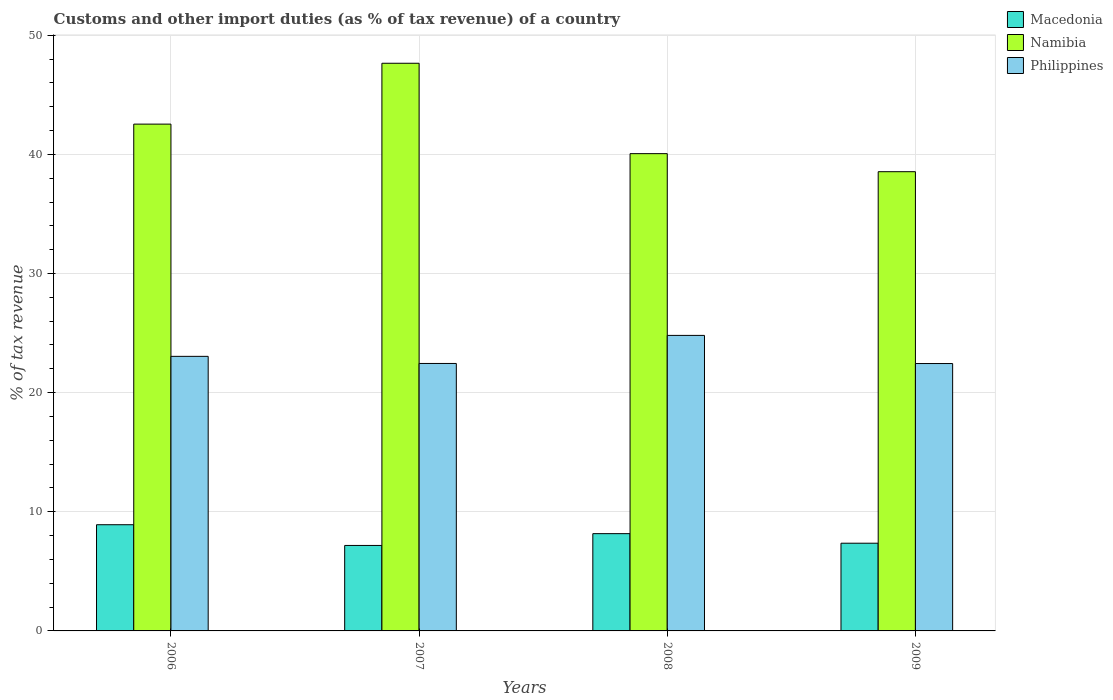How many different coloured bars are there?
Your answer should be compact. 3. How many groups of bars are there?
Your answer should be very brief. 4. What is the percentage of tax revenue from customs in Macedonia in 2008?
Your answer should be compact. 8.16. Across all years, what is the maximum percentage of tax revenue from customs in Namibia?
Keep it short and to the point. 47.65. Across all years, what is the minimum percentage of tax revenue from customs in Namibia?
Provide a short and direct response. 38.55. What is the total percentage of tax revenue from customs in Macedonia in the graph?
Your response must be concise. 31.62. What is the difference between the percentage of tax revenue from customs in Namibia in 2006 and that in 2009?
Give a very brief answer. 3.99. What is the difference between the percentage of tax revenue from customs in Namibia in 2007 and the percentage of tax revenue from customs in Macedonia in 2006?
Offer a very short reply. 38.73. What is the average percentage of tax revenue from customs in Namibia per year?
Provide a short and direct response. 42.2. In the year 2007, what is the difference between the percentage of tax revenue from customs in Macedonia and percentage of tax revenue from customs in Namibia?
Your answer should be compact. -40.47. In how many years, is the percentage of tax revenue from customs in Namibia greater than 14 %?
Your answer should be very brief. 4. What is the ratio of the percentage of tax revenue from customs in Namibia in 2006 to that in 2007?
Ensure brevity in your answer.  0.89. Is the difference between the percentage of tax revenue from customs in Macedonia in 2006 and 2008 greater than the difference between the percentage of tax revenue from customs in Namibia in 2006 and 2008?
Ensure brevity in your answer.  No. What is the difference between the highest and the second highest percentage of tax revenue from customs in Namibia?
Provide a short and direct response. 5.11. What is the difference between the highest and the lowest percentage of tax revenue from customs in Macedonia?
Ensure brevity in your answer.  1.74. In how many years, is the percentage of tax revenue from customs in Namibia greater than the average percentage of tax revenue from customs in Namibia taken over all years?
Give a very brief answer. 2. What does the 3rd bar from the left in 2007 represents?
Provide a short and direct response. Philippines. What does the 2nd bar from the right in 2008 represents?
Provide a succinct answer. Namibia. How many years are there in the graph?
Offer a terse response. 4. What is the difference between two consecutive major ticks on the Y-axis?
Provide a short and direct response. 10. Are the values on the major ticks of Y-axis written in scientific E-notation?
Ensure brevity in your answer.  No. Does the graph contain any zero values?
Keep it short and to the point. No. How many legend labels are there?
Provide a succinct answer. 3. How are the legend labels stacked?
Offer a terse response. Vertical. What is the title of the graph?
Provide a succinct answer. Customs and other import duties (as % of tax revenue) of a country. Does "Uruguay" appear as one of the legend labels in the graph?
Your response must be concise. No. What is the label or title of the X-axis?
Give a very brief answer. Years. What is the label or title of the Y-axis?
Keep it short and to the point. % of tax revenue. What is the % of tax revenue in Macedonia in 2006?
Ensure brevity in your answer.  8.91. What is the % of tax revenue in Namibia in 2006?
Give a very brief answer. 42.54. What is the % of tax revenue in Philippines in 2006?
Your response must be concise. 23.05. What is the % of tax revenue of Macedonia in 2007?
Make the answer very short. 7.17. What is the % of tax revenue in Namibia in 2007?
Make the answer very short. 47.65. What is the % of tax revenue in Philippines in 2007?
Ensure brevity in your answer.  22.45. What is the % of tax revenue in Macedonia in 2008?
Ensure brevity in your answer.  8.16. What is the % of tax revenue in Namibia in 2008?
Provide a short and direct response. 40.06. What is the % of tax revenue of Philippines in 2008?
Provide a succinct answer. 24.8. What is the % of tax revenue in Macedonia in 2009?
Your answer should be very brief. 7.36. What is the % of tax revenue in Namibia in 2009?
Make the answer very short. 38.55. What is the % of tax revenue of Philippines in 2009?
Your answer should be compact. 22.44. Across all years, what is the maximum % of tax revenue in Macedonia?
Give a very brief answer. 8.91. Across all years, what is the maximum % of tax revenue of Namibia?
Your response must be concise. 47.65. Across all years, what is the maximum % of tax revenue in Philippines?
Your answer should be compact. 24.8. Across all years, what is the minimum % of tax revenue in Macedonia?
Offer a very short reply. 7.17. Across all years, what is the minimum % of tax revenue of Namibia?
Provide a succinct answer. 38.55. Across all years, what is the minimum % of tax revenue in Philippines?
Your answer should be compact. 22.44. What is the total % of tax revenue in Macedonia in the graph?
Provide a short and direct response. 31.62. What is the total % of tax revenue of Namibia in the graph?
Keep it short and to the point. 168.79. What is the total % of tax revenue in Philippines in the graph?
Make the answer very short. 92.74. What is the difference between the % of tax revenue of Macedonia in 2006 and that in 2007?
Offer a very short reply. 1.74. What is the difference between the % of tax revenue of Namibia in 2006 and that in 2007?
Your response must be concise. -5.11. What is the difference between the % of tax revenue in Philippines in 2006 and that in 2007?
Keep it short and to the point. 0.6. What is the difference between the % of tax revenue in Macedonia in 2006 and that in 2008?
Give a very brief answer. 0.75. What is the difference between the % of tax revenue of Namibia in 2006 and that in 2008?
Your answer should be very brief. 2.48. What is the difference between the % of tax revenue of Philippines in 2006 and that in 2008?
Make the answer very short. -1.76. What is the difference between the % of tax revenue of Macedonia in 2006 and that in 2009?
Your answer should be very brief. 1.55. What is the difference between the % of tax revenue in Namibia in 2006 and that in 2009?
Your answer should be compact. 3.99. What is the difference between the % of tax revenue in Philippines in 2006 and that in 2009?
Provide a succinct answer. 0.6. What is the difference between the % of tax revenue in Macedonia in 2007 and that in 2008?
Make the answer very short. -0.99. What is the difference between the % of tax revenue in Namibia in 2007 and that in 2008?
Provide a short and direct response. 7.59. What is the difference between the % of tax revenue in Philippines in 2007 and that in 2008?
Provide a succinct answer. -2.36. What is the difference between the % of tax revenue in Macedonia in 2007 and that in 2009?
Provide a succinct answer. -0.19. What is the difference between the % of tax revenue of Namibia in 2007 and that in 2009?
Your answer should be very brief. 9.1. What is the difference between the % of tax revenue of Philippines in 2007 and that in 2009?
Offer a terse response. 0.01. What is the difference between the % of tax revenue in Macedonia in 2008 and that in 2009?
Offer a terse response. 0.8. What is the difference between the % of tax revenue of Namibia in 2008 and that in 2009?
Keep it short and to the point. 1.51. What is the difference between the % of tax revenue of Philippines in 2008 and that in 2009?
Ensure brevity in your answer.  2.36. What is the difference between the % of tax revenue in Macedonia in 2006 and the % of tax revenue in Namibia in 2007?
Your response must be concise. -38.73. What is the difference between the % of tax revenue of Macedonia in 2006 and the % of tax revenue of Philippines in 2007?
Keep it short and to the point. -13.54. What is the difference between the % of tax revenue in Namibia in 2006 and the % of tax revenue in Philippines in 2007?
Give a very brief answer. 20.09. What is the difference between the % of tax revenue of Macedonia in 2006 and the % of tax revenue of Namibia in 2008?
Provide a succinct answer. -31.15. What is the difference between the % of tax revenue of Macedonia in 2006 and the % of tax revenue of Philippines in 2008?
Make the answer very short. -15.89. What is the difference between the % of tax revenue of Namibia in 2006 and the % of tax revenue of Philippines in 2008?
Make the answer very short. 17.73. What is the difference between the % of tax revenue in Macedonia in 2006 and the % of tax revenue in Namibia in 2009?
Your answer should be very brief. -29.63. What is the difference between the % of tax revenue in Macedonia in 2006 and the % of tax revenue in Philippines in 2009?
Keep it short and to the point. -13.53. What is the difference between the % of tax revenue of Namibia in 2006 and the % of tax revenue of Philippines in 2009?
Ensure brevity in your answer.  20.1. What is the difference between the % of tax revenue of Macedonia in 2007 and the % of tax revenue of Namibia in 2008?
Offer a very short reply. -32.88. What is the difference between the % of tax revenue in Macedonia in 2007 and the % of tax revenue in Philippines in 2008?
Your answer should be very brief. -17.63. What is the difference between the % of tax revenue of Namibia in 2007 and the % of tax revenue of Philippines in 2008?
Keep it short and to the point. 22.84. What is the difference between the % of tax revenue in Macedonia in 2007 and the % of tax revenue in Namibia in 2009?
Give a very brief answer. -31.37. What is the difference between the % of tax revenue in Macedonia in 2007 and the % of tax revenue in Philippines in 2009?
Keep it short and to the point. -15.27. What is the difference between the % of tax revenue of Namibia in 2007 and the % of tax revenue of Philippines in 2009?
Offer a very short reply. 25.2. What is the difference between the % of tax revenue in Macedonia in 2008 and the % of tax revenue in Namibia in 2009?
Offer a very short reply. -30.38. What is the difference between the % of tax revenue of Macedonia in 2008 and the % of tax revenue of Philippines in 2009?
Offer a terse response. -14.28. What is the difference between the % of tax revenue of Namibia in 2008 and the % of tax revenue of Philippines in 2009?
Provide a short and direct response. 17.62. What is the average % of tax revenue of Macedonia per year?
Provide a succinct answer. 7.9. What is the average % of tax revenue of Namibia per year?
Offer a terse response. 42.2. What is the average % of tax revenue of Philippines per year?
Your response must be concise. 23.19. In the year 2006, what is the difference between the % of tax revenue in Macedonia and % of tax revenue in Namibia?
Your response must be concise. -33.62. In the year 2006, what is the difference between the % of tax revenue in Macedonia and % of tax revenue in Philippines?
Your response must be concise. -14.13. In the year 2006, what is the difference between the % of tax revenue in Namibia and % of tax revenue in Philippines?
Provide a short and direct response. 19.49. In the year 2007, what is the difference between the % of tax revenue in Macedonia and % of tax revenue in Namibia?
Make the answer very short. -40.47. In the year 2007, what is the difference between the % of tax revenue in Macedonia and % of tax revenue in Philippines?
Your answer should be compact. -15.27. In the year 2007, what is the difference between the % of tax revenue in Namibia and % of tax revenue in Philippines?
Give a very brief answer. 25.2. In the year 2008, what is the difference between the % of tax revenue of Macedonia and % of tax revenue of Namibia?
Your answer should be compact. -31.89. In the year 2008, what is the difference between the % of tax revenue of Macedonia and % of tax revenue of Philippines?
Offer a terse response. -16.64. In the year 2008, what is the difference between the % of tax revenue in Namibia and % of tax revenue in Philippines?
Your answer should be compact. 15.25. In the year 2009, what is the difference between the % of tax revenue of Macedonia and % of tax revenue of Namibia?
Your response must be concise. -31.18. In the year 2009, what is the difference between the % of tax revenue of Macedonia and % of tax revenue of Philippines?
Keep it short and to the point. -15.08. In the year 2009, what is the difference between the % of tax revenue of Namibia and % of tax revenue of Philippines?
Provide a succinct answer. 16.1. What is the ratio of the % of tax revenue of Macedonia in 2006 to that in 2007?
Make the answer very short. 1.24. What is the ratio of the % of tax revenue of Namibia in 2006 to that in 2007?
Offer a terse response. 0.89. What is the ratio of the % of tax revenue in Philippines in 2006 to that in 2007?
Your answer should be compact. 1.03. What is the ratio of the % of tax revenue of Macedonia in 2006 to that in 2008?
Your answer should be very brief. 1.09. What is the ratio of the % of tax revenue of Namibia in 2006 to that in 2008?
Your answer should be compact. 1.06. What is the ratio of the % of tax revenue of Philippines in 2006 to that in 2008?
Provide a succinct answer. 0.93. What is the ratio of the % of tax revenue of Macedonia in 2006 to that in 2009?
Offer a very short reply. 1.21. What is the ratio of the % of tax revenue of Namibia in 2006 to that in 2009?
Provide a short and direct response. 1.1. What is the ratio of the % of tax revenue in Philippines in 2006 to that in 2009?
Offer a terse response. 1.03. What is the ratio of the % of tax revenue in Macedonia in 2007 to that in 2008?
Provide a succinct answer. 0.88. What is the ratio of the % of tax revenue of Namibia in 2007 to that in 2008?
Offer a very short reply. 1.19. What is the ratio of the % of tax revenue in Philippines in 2007 to that in 2008?
Provide a succinct answer. 0.91. What is the ratio of the % of tax revenue of Macedonia in 2007 to that in 2009?
Ensure brevity in your answer.  0.97. What is the ratio of the % of tax revenue of Namibia in 2007 to that in 2009?
Keep it short and to the point. 1.24. What is the ratio of the % of tax revenue of Philippines in 2007 to that in 2009?
Your answer should be very brief. 1. What is the ratio of the % of tax revenue of Macedonia in 2008 to that in 2009?
Keep it short and to the point. 1.11. What is the ratio of the % of tax revenue of Namibia in 2008 to that in 2009?
Provide a succinct answer. 1.04. What is the ratio of the % of tax revenue in Philippines in 2008 to that in 2009?
Make the answer very short. 1.11. What is the difference between the highest and the second highest % of tax revenue of Macedonia?
Offer a terse response. 0.75. What is the difference between the highest and the second highest % of tax revenue of Namibia?
Your answer should be very brief. 5.11. What is the difference between the highest and the second highest % of tax revenue of Philippines?
Provide a succinct answer. 1.76. What is the difference between the highest and the lowest % of tax revenue in Macedonia?
Give a very brief answer. 1.74. What is the difference between the highest and the lowest % of tax revenue in Namibia?
Your answer should be compact. 9.1. What is the difference between the highest and the lowest % of tax revenue in Philippines?
Your answer should be very brief. 2.36. 